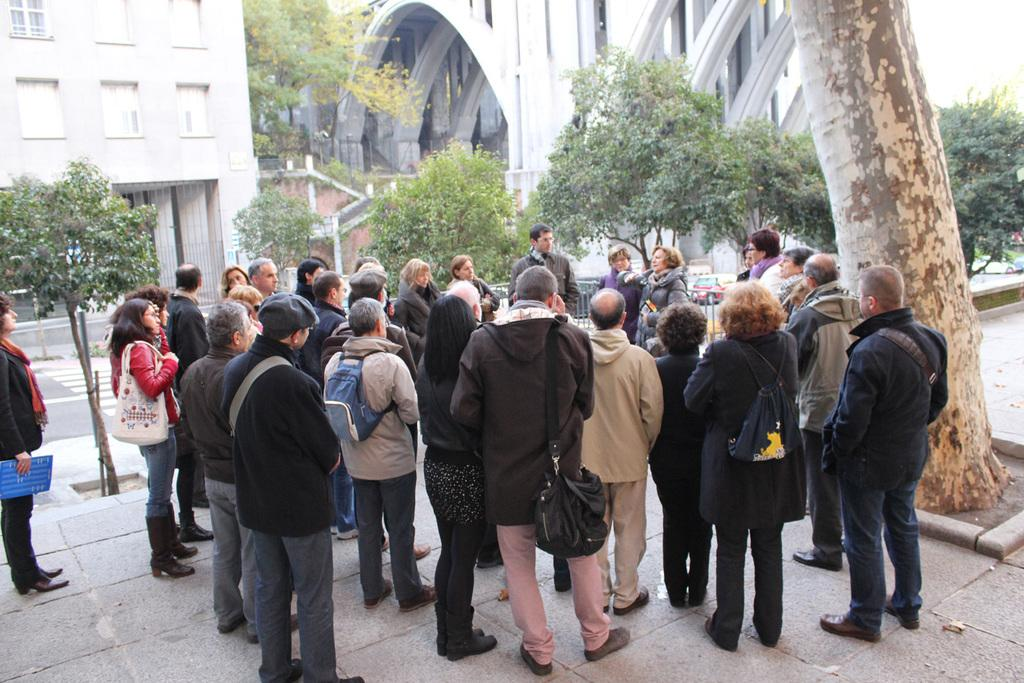What are the people in the image doing? The people in the image are standing on a footpath. What can be seen in the background of the image? There are trees, a road, and buildings in the background of the image. What type of chair can be seen in the image? There is no chair present in the image. What sound does the bell make in the image? There is no bell present in the image. 